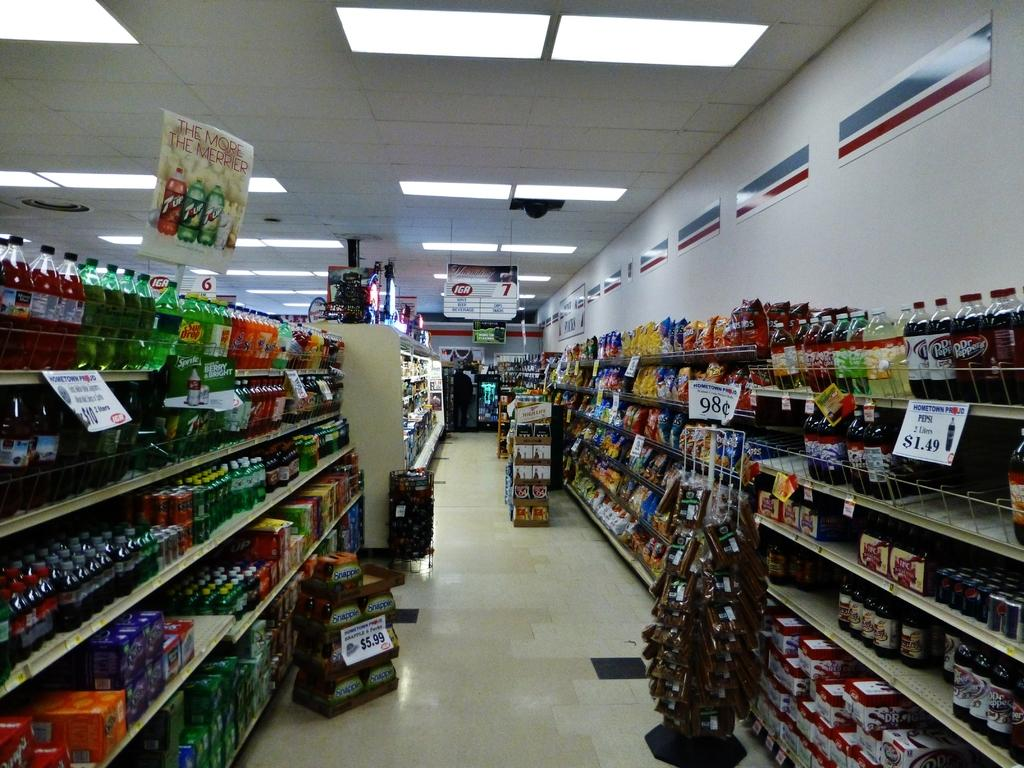<image>
Describe the image concisely. A beverage isle in a IGA grocery store. 